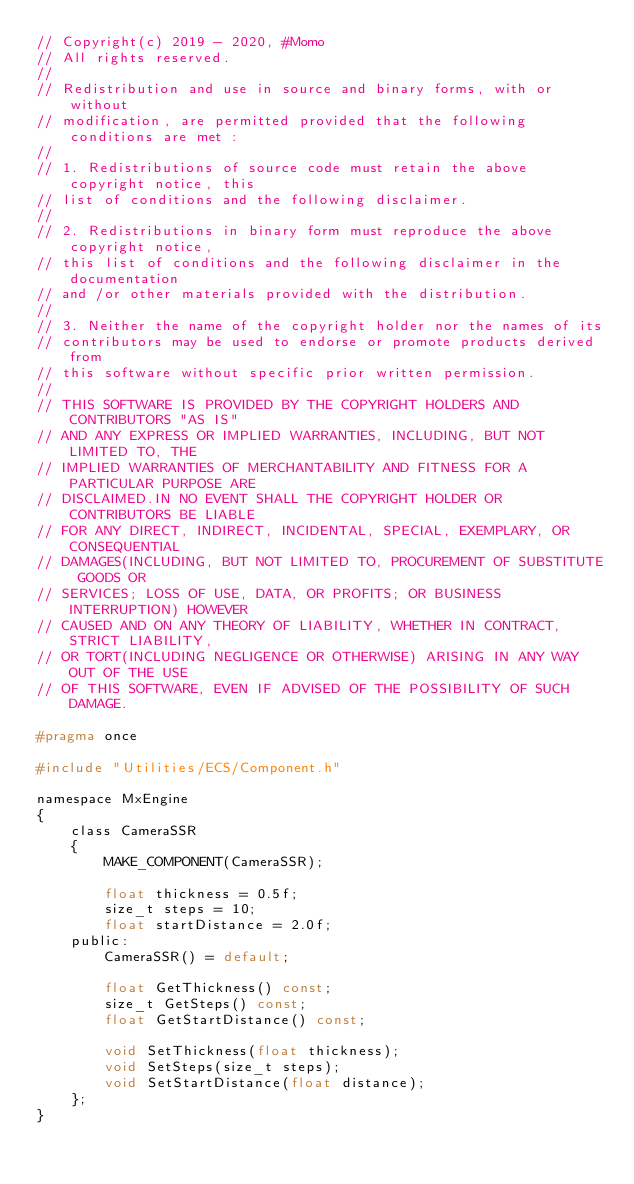<code> <loc_0><loc_0><loc_500><loc_500><_C_>// Copyright(c) 2019 - 2020, #Momo
// All rights reserved.
// 
// Redistribution and use in source and binary forms, with or without
// modification, are permitted provided that the following conditions are met :
// 
// 1. Redistributions of source code must retain the above copyright notice, this
// list of conditions and the following disclaimer.
// 
// 2. Redistributions in binary form must reproduce the above copyright notice,
// this list of conditions and the following disclaimer in the documentation
// and /or other materials provided with the distribution.
// 
// 3. Neither the name of the copyright holder nor the names of its
// contributors may be used to endorse or promote products derived from
// this software without specific prior written permission.
// 
// THIS SOFTWARE IS PROVIDED BY THE COPYRIGHT HOLDERS AND CONTRIBUTORS "AS IS"
// AND ANY EXPRESS OR IMPLIED WARRANTIES, INCLUDING, BUT NOT LIMITED TO, THE
// IMPLIED WARRANTIES OF MERCHANTABILITY AND FITNESS FOR A PARTICULAR PURPOSE ARE
// DISCLAIMED.IN NO EVENT SHALL THE COPYRIGHT HOLDER OR CONTRIBUTORS BE LIABLE
// FOR ANY DIRECT, INDIRECT, INCIDENTAL, SPECIAL, EXEMPLARY, OR CONSEQUENTIAL
// DAMAGES(INCLUDING, BUT NOT LIMITED TO, PROCUREMENT OF SUBSTITUTE GOODS OR
// SERVICES; LOSS OF USE, DATA, OR PROFITS; OR BUSINESS INTERRUPTION) HOWEVER
// CAUSED AND ON ANY THEORY OF LIABILITY, WHETHER IN CONTRACT, STRICT LIABILITY,
// OR TORT(INCLUDING NEGLIGENCE OR OTHERWISE) ARISING IN ANY WAY OUT OF THE USE
// OF THIS SOFTWARE, EVEN IF ADVISED OF THE POSSIBILITY OF SUCH DAMAGE.

#pragma once

#include "Utilities/ECS/Component.h"

namespace MxEngine
{
    class CameraSSR
    {
        MAKE_COMPONENT(CameraSSR);

        float thickness = 0.5f;
        size_t steps = 10;
        float startDistance = 2.0f;
    public:
        CameraSSR() = default;

        float GetThickness() const;
        size_t GetSteps() const;
        float GetStartDistance() const;

        void SetThickness(float thickness);
        void SetSteps(size_t steps);
        void SetStartDistance(float distance);
    };
}</code> 